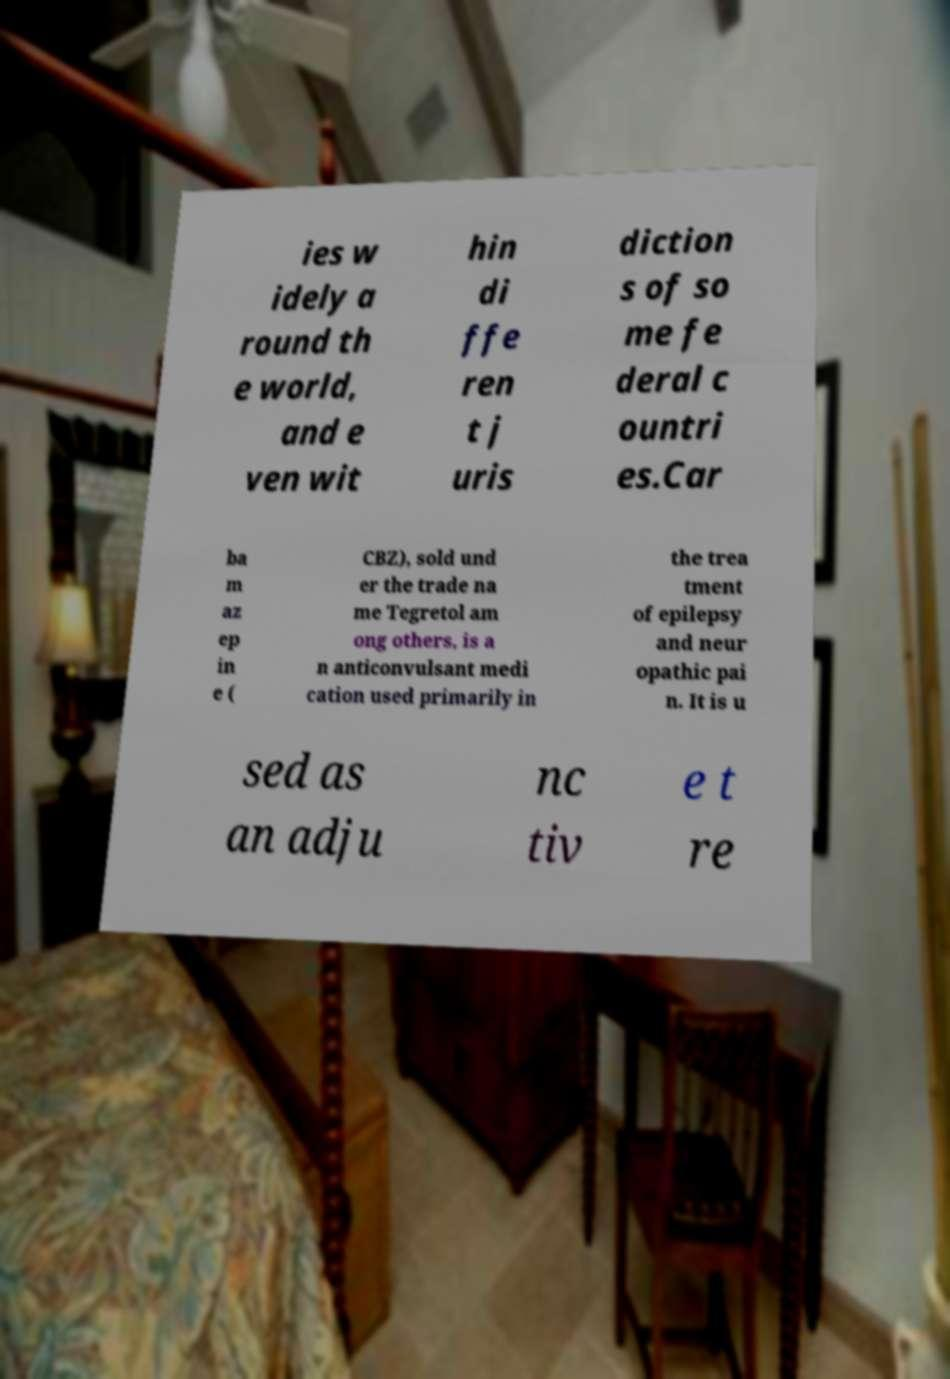Could you assist in decoding the text presented in this image and type it out clearly? ies w idely a round th e world, and e ven wit hin di ffe ren t j uris diction s of so me fe deral c ountri es.Car ba m az ep in e ( CBZ), sold und er the trade na me Tegretol am ong others, is a n anticonvulsant medi cation used primarily in the trea tment of epilepsy and neur opathic pai n. It is u sed as an adju nc tiv e t re 